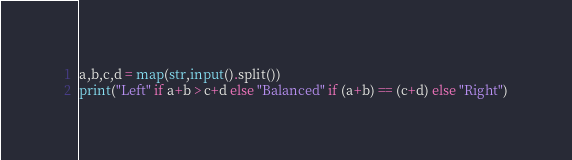Convert code to text. <code><loc_0><loc_0><loc_500><loc_500><_Python_>a,b,c,d = map(str,input().split())
print("Left" if a+b > c+d else "Balanced" if (a+b) == (c+d) else "Right")
</code> 